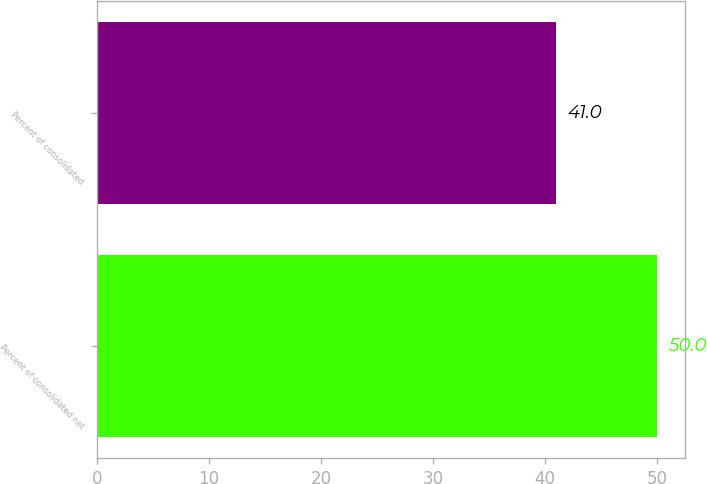Convert chart to OTSL. <chart><loc_0><loc_0><loc_500><loc_500><bar_chart><fcel>Percent of consolidated net<fcel>Percent of consolidated<nl><fcel>50<fcel>41<nl></chart> 